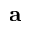Convert formula to latex. <formula><loc_0><loc_0><loc_500><loc_500>\delta a</formula> 